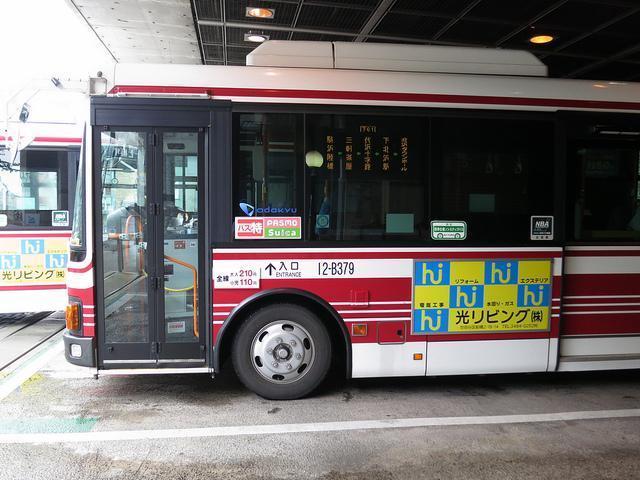How many buses can be seen?
Give a very brief answer. 2. How many decks does the bus have?
Give a very brief answer. 1. How many buses are visible?
Give a very brief answer. 2. 